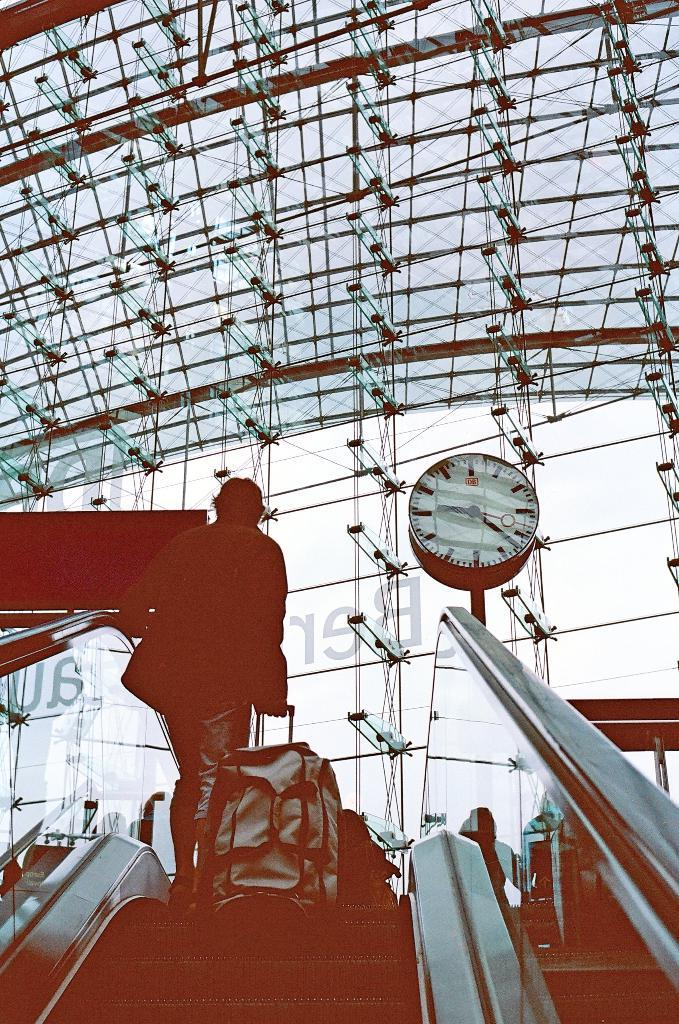What is the person in the image doing? The person is holding a trolley bag and standing on an escalator. What might the person be carrying in the trolley bag? It is not possible to determine what the person is carrying in the trolley bag from the image. What can be seen in the background of the image? There is a clock and glass doors visible in the image. What type of shame can be seen on the person's face in the image? There is no indication of shame on the person's face in the image. How does the fog affect the visibility in the image? There is no fog present in the image, so it does not affect the visibility. 